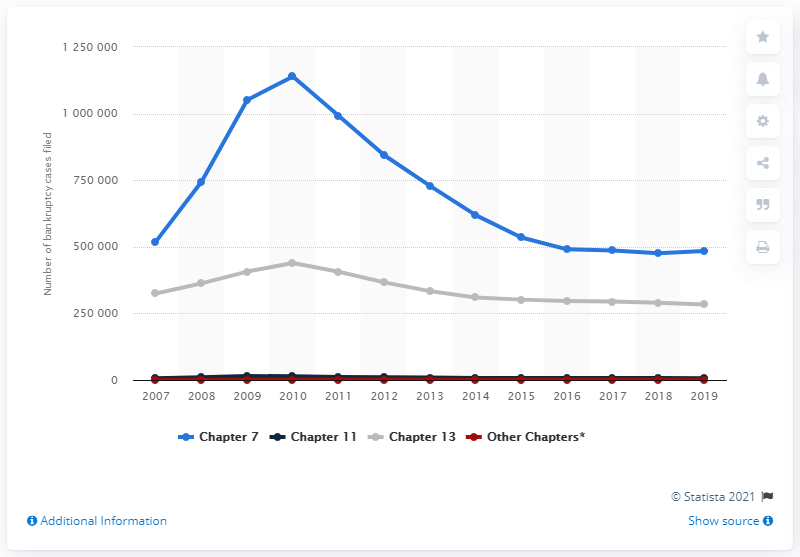Outline some significant characteristics in this image. In 2010, a total of 113,9601 chapter 7 bankruptcies were filed. 